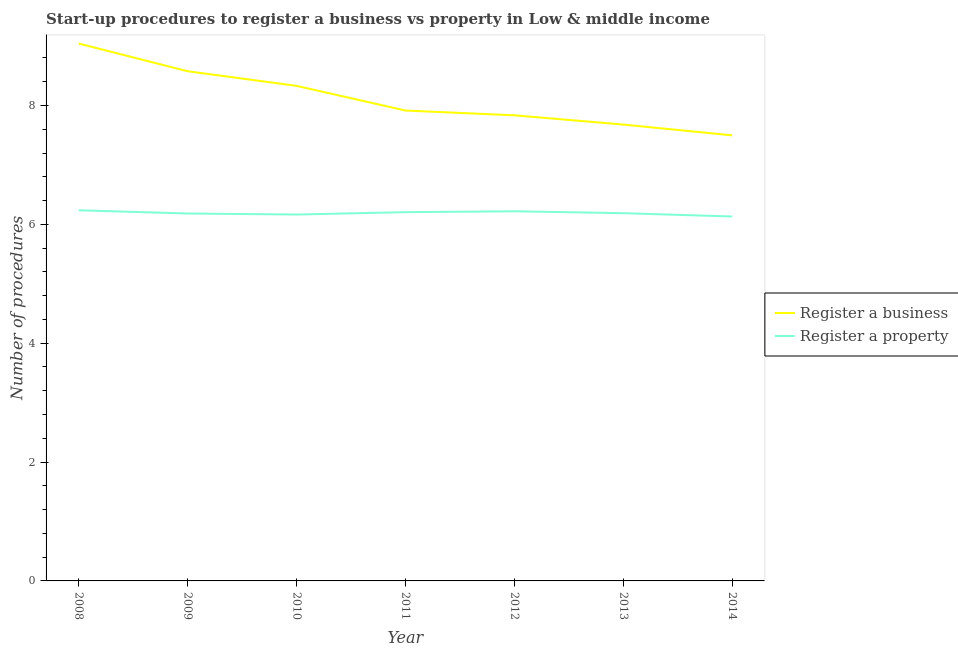How many different coloured lines are there?
Your answer should be very brief. 2. Does the line corresponding to number of procedures to register a business intersect with the line corresponding to number of procedures to register a property?
Ensure brevity in your answer.  No. What is the number of procedures to register a property in 2011?
Your answer should be very brief. 6.21. Across all years, what is the maximum number of procedures to register a property?
Your answer should be very brief. 6.24. Across all years, what is the minimum number of procedures to register a business?
Keep it short and to the point. 7.5. In which year was the number of procedures to register a business maximum?
Keep it short and to the point. 2008. What is the total number of procedures to register a business in the graph?
Your answer should be very brief. 56.88. What is the difference between the number of procedures to register a property in 2012 and that in 2014?
Keep it short and to the point. 0.09. What is the difference between the number of procedures to register a business in 2012 and the number of procedures to register a property in 2013?
Keep it short and to the point. 1.65. What is the average number of procedures to register a business per year?
Ensure brevity in your answer.  8.13. In the year 2012, what is the difference between the number of procedures to register a property and number of procedures to register a business?
Provide a succinct answer. -1.61. What is the ratio of the number of procedures to register a business in 2012 to that in 2013?
Your answer should be compact. 1.02. What is the difference between the highest and the second highest number of procedures to register a property?
Make the answer very short. 0.02. What is the difference between the highest and the lowest number of procedures to register a business?
Provide a succinct answer. 1.55. Is the number of procedures to register a business strictly greater than the number of procedures to register a property over the years?
Give a very brief answer. Yes. How many lines are there?
Your answer should be compact. 2. What is the difference between two consecutive major ticks on the Y-axis?
Provide a short and direct response. 2. Are the values on the major ticks of Y-axis written in scientific E-notation?
Ensure brevity in your answer.  No. Does the graph contain any zero values?
Your response must be concise. No. Where does the legend appear in the graph?
Provide a short and direct response. Center right. How many legend labels are there?
Provide a succinct answer. 2. What is the title of the graph?
Your answer should be compact. Start-up procedures to register a business vs property in Low & middle income. Does "% of GNI" appear as one of the legend labels in the graph?
Ensure brevity in your answer.  No. What is the label or title of the X-axis?
Your answer should be very brief. Year. What is the label or title of the Y-axis?
Provide a succinct answer. Number of procedures. What is the Number of procedures in Register a business in 2008?
Offer a terse response. 9.04. What is the Number of procedures of Register a property in 2008?
Offer a terse response. 6.24. What is the Number of procedures in Register a business in 2009?
Offer a very short reply. 8.58. What is the Number of procedures of Register a property in 2009?
Your answer should be very brief. 6.18. What is the Number of procedures of Register a business in 2010?
Provide a short and direct response. 8.33. What is the Number of procedures in Register a property in 2010?
Provide a short and direct response. 6.17. What is the Number of procedures of Register a business in 2011?
Offer a very short reply. 7.92. What is the Number of procedures of Register a property in 2011?
Give a very brief answer. 6.21. What is the Number of procedures of Register a business in 2012?
Provide a succinct answer. 7.83. What is the Number of procedures of Register a property in 2012?
Offer a very short reply. 6.22. What is the Number of procedures in Register a business in 2013?
Your answer should be very brief. 7.68. What is the Number of procedures in Register a property in 2013?
Your answer should be very brief. 6.19. What is the Number of procedures in Register a business in 2014?
Your answer should be compact. 7.5. What is the Number of procedures in Register a property in 2014?
Keep it short and to the point. 6.13. Across all years, what is the maximum Number of procedures of Register a business?
Offer a very short reply. 9.04. Across all years, what is the maximum Number of procedures of Register a property?
Offer a terse response. 6.24. Across all years, what is the minimum Number of procedures of Register a business?
Your answer should be compact. 7.5. Across all years, what is the minimum Number of procedures in Register a property?
Your answer should be very brief. 6.13. What is the total Number of procedures of Register a business in the graph?
Provide a short and direct response. 56.88. What is the total Number of procedures of Register a property in the graph?
Make the answer very short. 43.33. What is the difference between the Number of procedures of Register a business in 2008 and that in 2009?
Offer a terse response. 0.47. What is the difference between the Number of procedures in Register a property in 2008 and that in 2009?
Offer a very short reply. 0.05. What is the difference between the Number of procedures in Register a business in 2008 and that in 2010?
Your answer should be compact. 0.71. What is the difference between the Number of procedures in Register a property in 2008 and that in 2010?
Give a very brief answer. 0.07. What is the difference between the Number of procedures in Register a business in 2008 and that in 2011?
Keep it short and to the point. 1.13. What is the difference between the Number of procedures of Register a property in 2008 and that in 2011?
Keep it short and to the point. 0.03. What is the difference between the Number of procedures in Register a business in 2008 and that in 2012?
Give a very brief answer. 1.21. What is the difference between the Number of procedures in Register a property in 2008 and that in 2012?
Offer a terse response. 0.02. What is the difference between the Number of procedures in Register a business in 2008 and that in 2013?
Provide a short and direct response. 1.36. What is the difference between the Number of procedures of Register a property in 2008 and that in 2013?
Offer a very short reply. 0.05. What is the difference between the Number of procedures in Register a business in 2008 and that in 2014?
Make the answer very short. 1.55. What is the difference between the Number of procedures in Register a property in 2008 and that in 2014?
Ensure brevity in your answer.  0.1. What is the difference between the Number of procedures in Register a business in 2009 and that in 2010?
Keep it short and to the point. 0.25. What is the difference between the Number of procedures of Register a property in 2009 and that in 2010?
Your response must be concise. 0.02. What is the difference between the Number of procedures of Register a business in 2009 and that in 2011?
Make the answer very short. 0.66. What is the difference between the Number of procedures of Register a property in 2009 and that in 2011?
Provide a succinct answer. -0.02. What is the difference between the Number of procedures of Register a business in 2009 and that in 2012?
Your response must be concise. 0.74. What is the difference between the Number of procedures in Register a property in 2009 and that in 2012?
Your response must be concise. -0.04. What is the difference between the Number of procedures of Register a business in 2009 and that in 2013?
Your answer should be very brief. 0.9. What is the difference between the Number of procedures in Register a property in 2009 and that in 2013?
Your response must be concise. -0.01. What is the difference between the Number of procedures of Register a business in 2009 and that in 2014?
Give a very brief answer. 1.08. What is the difference between the Number of procedures of Register a property in 2009 and that in 2014?
Your answer should be very brief. 0.05. What is the difference between the Number of procedures in Register a business in 2010 and that in 2011?
Your answer should be very brief. 0.42. What is the difference between the Number of procedures in Register a property in 2010 and that in 2011?
Ensure brevity in your answer.  -0.04. What is the difference between the Number of procedures in Register a business in 2010 and that in 2012?
Your answer should be compact. 0.5. What is the difference between the Number of procedures of Register a property in 2010 and that in 2012?
Keep it short and to the point. -0.05. What is the difference between the Number of procedures in Register a business in 2010 and that in 2013?
Offer a very short reply. 0.65. What is the difference between the Number of procedures in Register a property in 2010 and that in 2013?
Keep it short and to the point. -0.02. What is the difference between the Number of procedures in Register a business in 2010 and that in 2014?
Provide a short and direct response. 0.83. What is the difference between the Number of procedures in Register a property in 2010 and that in 2014?
Offer a very short reply. 0.03. What is the difference between the Number of procedures in Register a business in 2011 and that in 2012?
Your response must be concise. 0.08. What is the difference between the Number of procedures of Register a property in 2011 and that in 2012?
Offer a very short reply. -0.01. What is the difference between the Number of procedures in Register a business in 2011 and that in 2013?
Offer a terse response. 0.24. What is the difference between the Number of procedures in Register a property in 2011 and that in 2013?
Provide a succinct answer. 0.02. What is the difference between the Number of procedures of Register a business in 2011 and that in 2014?
Offer a very short reply. 0.42. What is the difference between the Number of procedures in Register a property in 2011 and that in 2014?
Offer a terse response. 0.07. What is the difference between the Number of procedures of Register a business in 2012 and that in 2013?
Give a very brief answer. 0.16. What is the difference between the Number of procedures of Register a property in 2012 and that in 2013?
Offer a terse response. 0.03. What is the difference between the Number of procedures of Register a business in 2012 and that in 2014?
Offer a terse response. 0.34. What is the difference between the Number of procedures of Register a property in 2012 and that in 2014?
Keep it short and to the point. 0.09. What is the difference between the Number of procedures in Register a business in 2013 and that in 2014?
Ensure brevity in your answer.  0.18. What is the difference between the Number of procedures in Register a property in 2013 and that in 2014?
Make the answer very short. 0.06. What is the difference between the Number of procedures of Register a business in 2008 and the Number of procedures of Register a property in 2009?
Your response must be concise. 2.86. What is the difference between the Number of procedures of Register a business in 2008 and the Number of procedures of Register a property in 2010?
Make the answer very short. 2.88. What is the difference between the Number of procedures of Register a business in 2008 and the Number of procedures of Register a property in 2011?
Your answer should be very brief. 2.84. What is the difference between the Number of procedures of Register a business in 2008 and the Number of procedures of Register a property in 2012?
Your response must be concise. 2.82. What is the difference between the Number of procedures in Register a business in 2008 and the Number of procedures in Register a property in 2013?
Your response must be concise. 2.85. What is the difference between the Number of procedures of Register a business in 2008 and the Number of procedures of Register a property in 2014?
Offer a very short reply. 2.91. What is the difference between the Number of procedures in Register a business in 2009 and the Number of procedures in Register a property in 2010?
Provide a short and direct response. 2.41. What is the difference between the Number of procedures in Register a business in 2009 and the Number of procedures in Register a property in 2011?
Offer a terse response. 2.37. What is the difference between the Number of procedures of Register a business in 2009 and the Number of procedures of Register a property in 2012?
Your answer should be very brief. 2.36. What is the difference between the Number of procedures in Register a business in 2009 and the Number of procedures in Register a property in 2013?
Offer a terse response. 2.39. What is the difference between the Number of procedures of Register a business in 2009 and the Number of procedures of Register a property in 2014?
Provide a short and direct response. 2.44. What is the difference between the Number of procedures in Register a business in 2010 and the Number of procedures in Register a property in 2011?
Keep it short and to the point. 2.13. What is the difference between the Number of procedures in Register a business in 2010 and the Number of procedures in Register a property in 2012?
Your answer should be very brief. 2.11. What is the difference between the Number of procedures in Register a business in 2010 and the Number of procedures in Register a property in 2013?
Provide a succinct answer. 2.14. What is the difference between the Number of procedures in Register a business in 2010 and the Number of procedures in Register a property in 2014?
Make the answer very short. 2.2. What is the difference between the Number of procedures of Register a business in 2011 and the Number of procedures of Register a property in 2012?
Give a very brief answer. 1.7. What is the difference between the Number of procedures of Register a business in 2011 and the Number of procedures of Register a property in 2013?
Your answer should be compact. 1.73. What is the difference between the Number of procedures of Register a business in 2011 and the Number of procedures of Register a property in 2014?
Make the answer very short. 1.78. What is the difference between the Number of procedures of Register a business in 2012 and the Number of procedures of Register a property in 2013?
Provide a short and direct response. 1.65. What is the difference between the Number of procedures of Register a business in 2012 and the Number of procedures of Register a property in 2014?
Provide a short and direct response. 1.7. What is the difference between the Number of procedures of Register a business in 2013 and the Number of procedures of Register a property in 2014?
Provide a short and direct response. 1.55. What is the average Number of procedures in Register a business per year?
Offer a terse response. 8.13. What is the average Number of procedures in Register a property per year?
Your answer should be very brief. 6.19. In the year 2008, what is the difference between the Number of procedures in Register a business and Number of procedures in Register a property?
Your response must be concise. 2.81. In the year 2009, what is the difference between the Number of procedures of Register a business and Number of procedures of Register a property?
Your answer should be compact. 2.39. In the year 2010, what is the difference between the Number of procedures in Register a business and Number of procedures in Register a property?
Your response must be concise. 2.17. In the year 2011, what is the difference between the Number of procedures in Register a business and Number of procedures in Register a property?
Provide a short and direct response. 1.71. In the year 2012, what is the difference between the Number of procedures of Register a business and Number of procedures of Register a property?
Offer a terse response. 1.61. In the year 2013, what is the difference between the Number of procedures of Register a business and Number of procedures of Register a property?
Offer a terse response. 1.49. In the year 2014, what is the difference between the Number of procedures in Register a business and Number of procedures in Register a property?
Your response must be concise. 1.37. What is the ratio of the Number of procedures of Register a business in 2008 to that in 2009?
Give a very brief answer. 1.05. What is the ratio of the Number of procedures in Register a property in 2008 to that in 2009?
Offer a very short reply. 1.01. What is the ratio of the Number of procedures of Register a business in 2008 to that in 2010?
Provide a succinct answer. 1.09. What is the ratio of the Number of procedures of Register a property in 2008 to that in 2010?
Give a very brief answer. 1.01. What is the ratio of the Number of procedures in Register a business in 2008 to that in 2011?
Ensure brevity in your answer.  1.14. What is the ratio of the Number of procedures in Register a business in 2008 to that in 2012?
Provide a succinct answer. 1.15. What is the ratio of the Number of procedures of Register a property in 2008 to that in 2012?
Your answer should be compact. 1. What is the ratio of the Number of procedures in Register a business in 2008 to that in 2013?
Your answer should be compact. 1.18. What is the ratio of the Number of procedures of Register a property in 2008 to that in 2013?
Your answer should be compact. 1.01. What is the ratio of the Number of procedures in Register a business in 2008 to that in 2014?
Provide a short and direct response. 1.21. What is the ratio of the Number of procedures in Register a property in 2008 to that in 2014?
Ensure brevity in your answer.  1.02. What is the ratio of the Number of procedures in Register a business in 2009 to that in 2010?
Offer a very short reply. 1.03. What is the ratio of the Number of procedures in Register a property in 2009 to that in 2010?
Offer a very short reply. 1. What is the ratio of the Number of procedures of Register a business in 2009 to that in 2011?
Make the answer very short. 1.08. What is the ratio of the Number of procedures in Register a property in 2009 to that in 2011?
Give a very brief answer. 1. What is the ratio of the Number of procedures of Register a business in 2009 to that in 2012?
Provide a short and direct response. 1.09. What is the ratio of the Number of procedures of Register a property in 2009 to that in 2012?
Provide a succinct answer. 0.99. What is the ratio of the Number of procedures of Register a business in 2009 to that in 2013?
Ensure brevity in your answer.  1.12. What is the ratio of the Number of procedures of Register a property in 2009 to that in 2013?
Provide a succinct answer. 1. What is the ratio of the Number of procedures in Register a business in 2009 to that in 2014?
Your answer should be compact. 1.14. What is the ratio of the Number of procedures of Register a property in 2009 to that in 2014?
Make the answer very short. 1.01. What is the ratio of the Number of procedures in Register a business in 2010 to that in 2011?
Offer a very short reply. 1.05. What is the ratio of the Number of procedures of Register a business in 2010 to that in 2012?
Offer a terse response. 1.06. What is the ratio of the Number of procedures in Register a property in 2010 to that in 2012?
Ensure brevity in your answer.  0.99. What is the ratio of the Number of procedures in Register a business in 2010 to that in 2013?
Your answer should be very brief. 1.08. What is the ratio of the Number of procedures in Register a property in 2010 to that in 2013?
Your response must be concise. 1. What is the ratio of the Number of procedures in Register a property in 2010 to that in 2014?
Your response must be concise. 1.01. What is the ratio of the Number of procedures of Register a business in 2011 to that in 2012?
Ensure brevity in your answer.  1.01. What is the ratio of the Number of procedures in Register a business in 2011 to that in 2013?
Offer a terse response. 1.03. What is the ratio of the Number of procedures of Register a business in 2011 to that in 2014?
Provide a short and direct response. 1.06. What is the ratio of the Number of procedures of Register a property in 2011 to that in 2014?
Ensure brevity in your answer.  1.01. What is the ratio of the Number of procedures in Register a business in 2012 to that in 2013?
Offer a very short reply. 1.02. What is the ratio of the Number of procedures in Register a property in 2012 to that in 2013?
Keep it short and to the point. 1.01. What is the ratio of the Number of procedures in Register a business in 2012 to that in 2014?
Give a very brief answer. 1.04. What is the ratio of the Number of procedures of Register a property in 2012 to that in 2014?
Ensure brevity in your answer.  1.01. What is the ratio of the Number of procedures of Register a business in 2013 to that in 2014?
Your answer should be compact. 1.02. What is the ratio of the Number of procedures in Register a property in 2013 to that in 2014?
Your response must be concise. 1.01. What is the difference between the highest and the second highest Number of procedures in Register a business?
Your answer should be compact. 0.47. What is the difference between the highest and the second highest Number of procedures of Register a property?
Give a very brief answer. 0.02. What is the difference between the highest and the lowest Number of procedures of Register a business?
Your answer should be very brief. 1.55. What is the difference between the highest and the lowest Number of procedures in Register a property?
Keep it short and to the point. 0.1. 